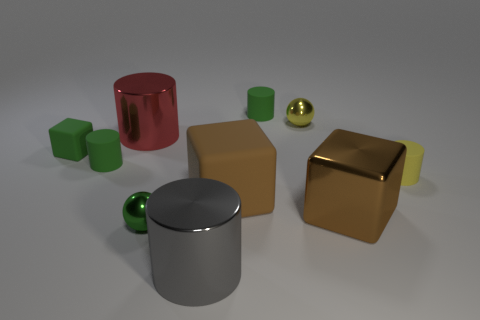Are any big brown metallic balls visible?
Your answer should be compact. No. Is the gray thing made of the same material as the yellow object in front of the big red object?
Your answer should be very brief. No. There is a green ball that is the same size as the green rubber cube; what is its material?
Your response must be concise. Metal. Are there any tiny yellow cubes made of the same material as the big gray object?
Offer a terse response. No. There is a big red cylinder that is on the left side of the ball that is on the left side of the gray cylinder; are there any big metal objects to the left of it?
Provide a succinct answer. No. What shape is the brown matte object that is the same size as the gray metallic cylinder?
Keep it short and to the point. Cube. Is the size of the green cylinder to the left of the gray cylinder the same as the red cylinder that is on the left side of the tiny green metallic ball?
Your answer should be compact. No. How many big gray blocks are there?
Your answer should be very brief. 0. What size is the green cylinder that is behind the big object that is behind the yellow rubber cylinder that is in front of the large red metal object?
Your response must be concise. Small. Do the shiny cube and the tiny cube have the same color?
Provide a short and direct response. No. 